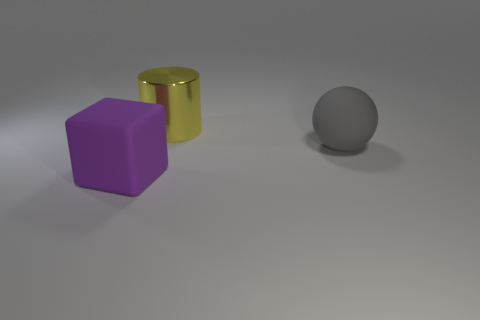What colors are present in the image, and which object corresponds to each color? In the image, there are three distinct colors associated with the objects: purple, gold, and gray. The purple color is on the cube, the gold color adorns the cylinder, and the gray color is the hue of the sphere. 